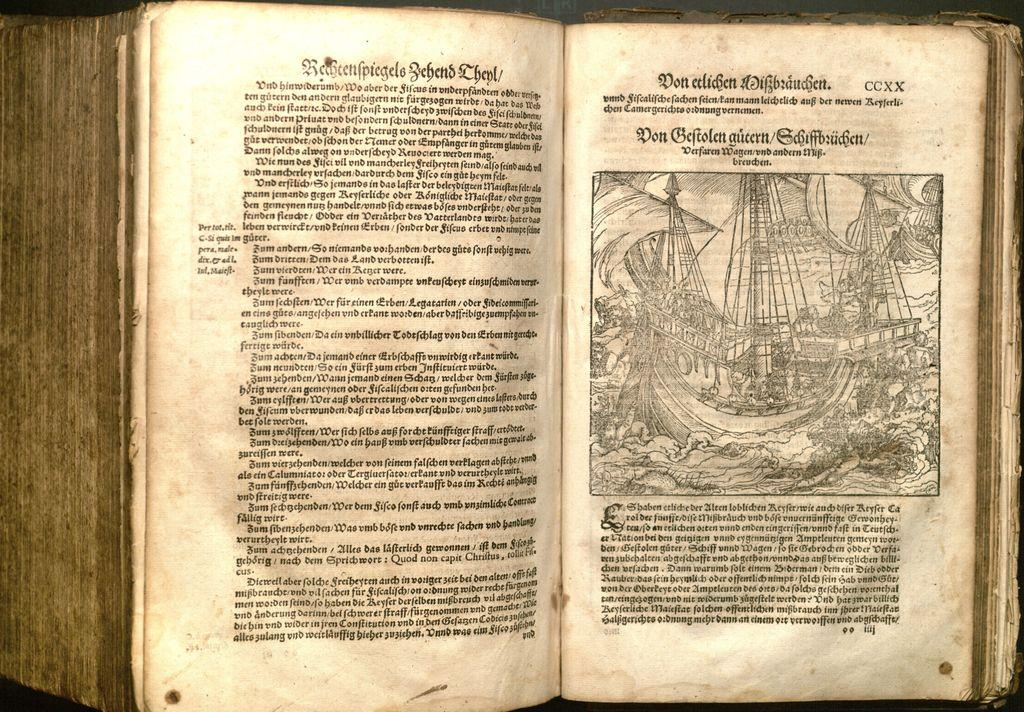<image>
Present a compact description of the photo's key features. A very old book is written in a foreign language and is open to page CCXX. 